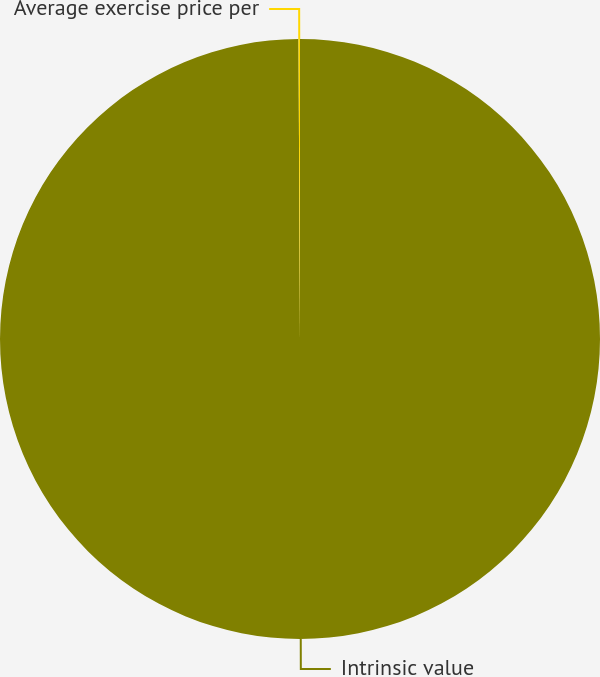Convert chart. <chart><loc_0><loc_0><loc_500><loc_500><pie_chart><fcel>Intrinsic value<fcel>Average exercise price per<nl><fcel>99.92%<fcel>0.08%<nl></chart> 